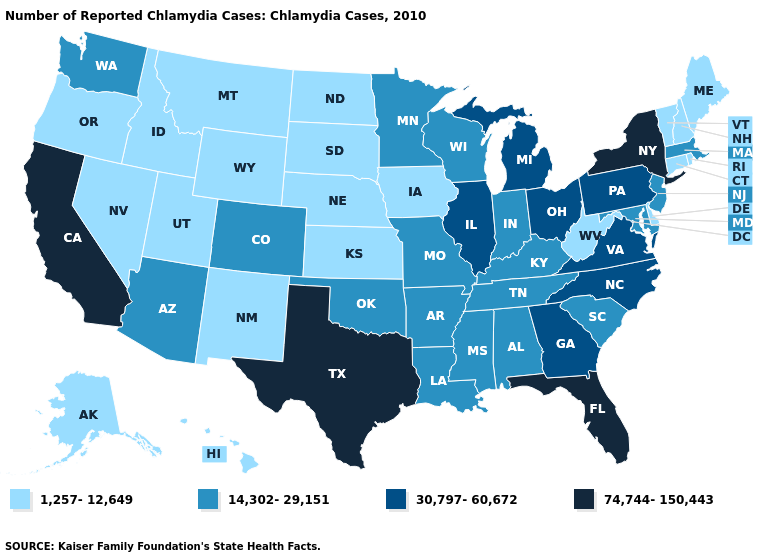Does South Dakota have a lower value than Hawaii?
Answer briefly. No. What is the highest value in states that border Arizona?
Write a very short answer. 74,744-150,443. Which states have the lowest value in the MidWest?
Concise answer only. Iowa, Kansas, Nebraska, North Dakota, South Dakota. Which states have the lowest value in the USA?
Write a very short answer. Alaska, Connecticut, Delaware, Hawaii, Idaho, Iowa, Kansas, Maine, Montana, Nebraska, Nevada, New Hampshire, New Mexico, North Dakota, Oregon, Rhode Island, South Dakota, Utah, Vermont, West Virginia, Wyoming. What is the highest value in states that border Nebraska?
Concise answer only. 14,302-29,151. What is the lowest value in the South?
Quick response, please. 1,257-12,649. What is the value of Maine?
Keep it brief. 1,257-12,649. Does the first symbol in the legend represent the smallest category?
Concise answer only. Yes. What is the value of Colorado?
Be succinct. 14,302-29,151. Name the states that have a value in the range 14,302-29,151?
Quick response, please. Alabama, Arizona, Arkansas, Colorado, Indiana, Kentucky, Louisiana, Maryland, Massachusetts, Minnesota, Mississippi, Missouri, New Jersey, Oklahoma, South Carolina, Tennessee, Washington, Wisconsin. Which states have the highest value in the USA?
Keep it brief. California, Florida, New York, Texas. Name the states that have a value in the range 1,257-12,649?
Write a very short answer. Alaska, Connecticut, Delaware, Hawaii, Idaho, Iowa, Kansas, Maine, Montana, Nebraska, Nevada, New Hampshire, New Mexico, North Dakota, Oregon, Rhode Island, South Dakota, Utah, Vermont, West Virginia, Wyoming. What is the highest value in the Northeast ?
Answer briefly. 74,744-150,443. What is the value of South Dakota?
Give a very brief answer. 1,257-12,649. Which states have the lowest value in the MidWest?
Short answer required. Iowa, Kansas, Nebraska, North Dakota, South Dakota. 